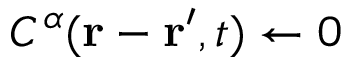<formula> <loc_0><loc_0><loc_500><loc_500>C ^ { \alpha } ( r - r ^ { \prime } , t ) \gets 0</formula> 